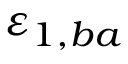Convert formula to latex. <formula><loc_0><loc_0><loc_500><loc_500>\varepsilon _ { 1 , b a }</formula> 